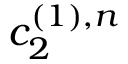Convert formula to latex. <formula><loc_0><loc_0><loc_500><loc_500>c _ { 2 } ^ { ( 1 ) , n }</formula> 